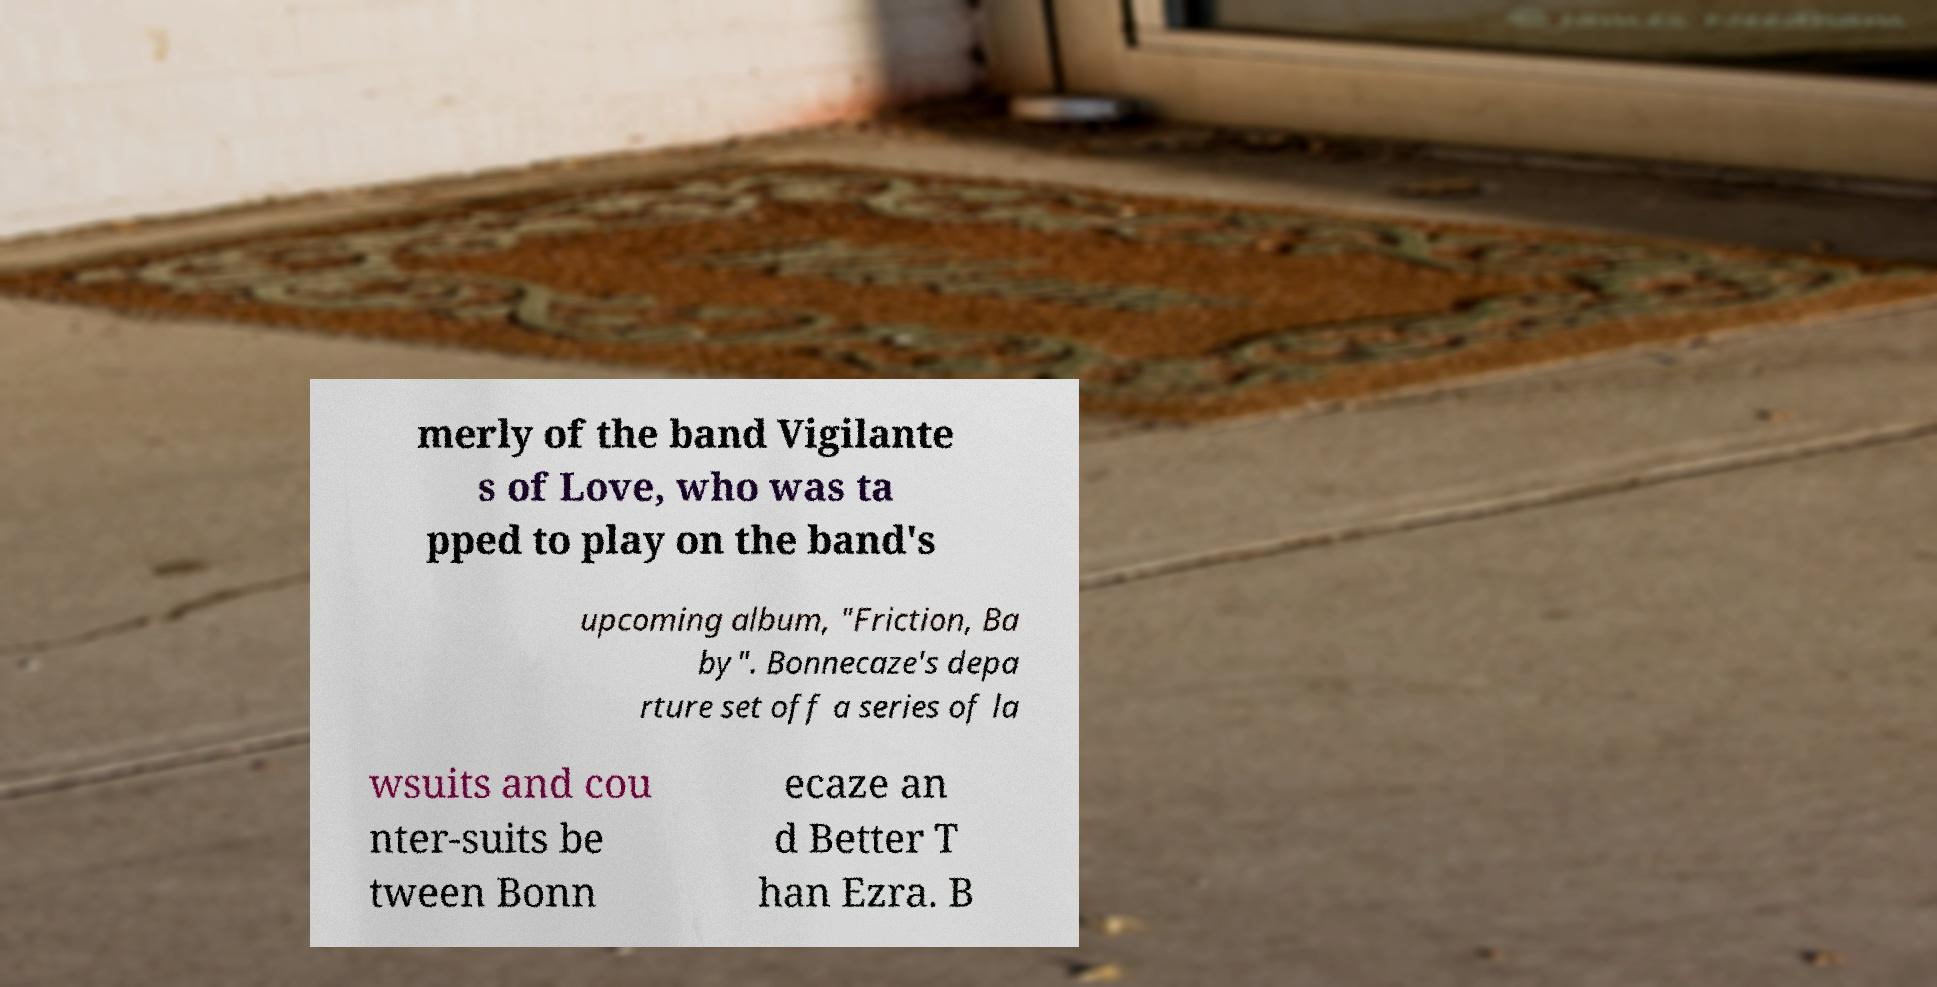Could you extract and type out the text from this image? merly of the band Vigilante s of Love, who was ta pped to play on the band's upcoming album, "Friction, Ba by". Bonnecaze's depa rture set off a series of la wsuits and cou nter-suits be tween Bonn ecaze an d Better T han Ezra. B 